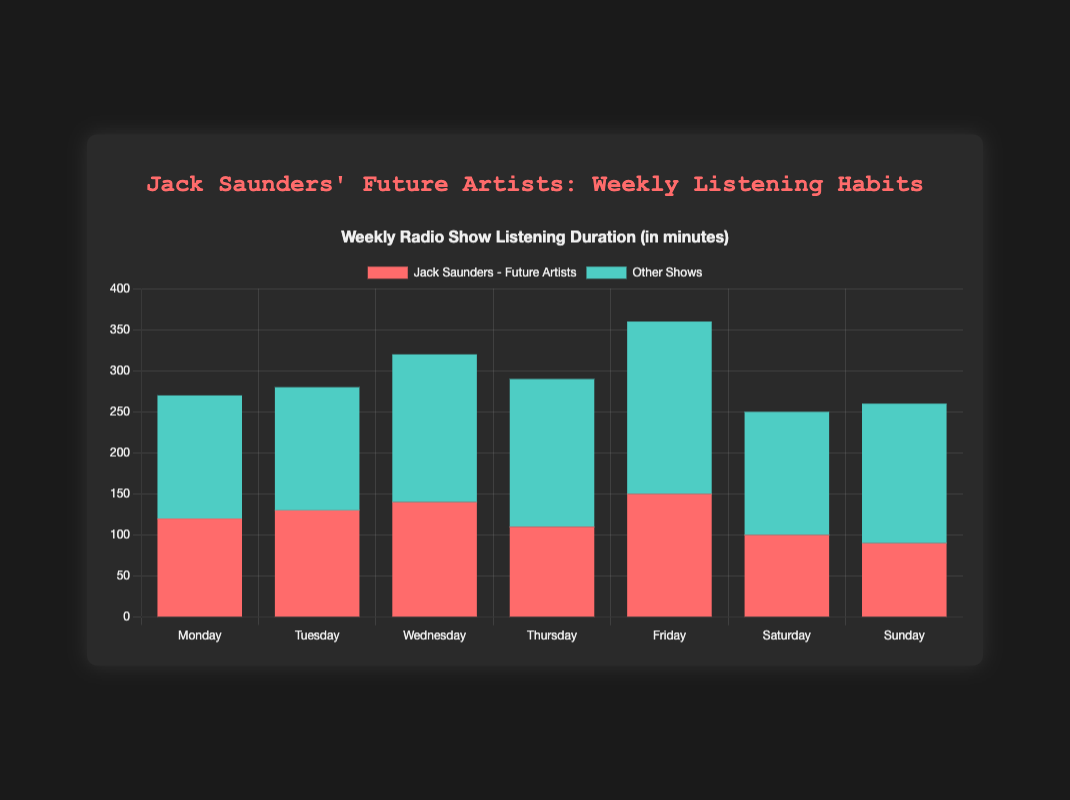Which day has the highest total listening duration? Look for the bar with the greatest height. The total height for each day is the sum of the durations. Friday has the highest total duration.
Answer: Friday Which day has the least amount of listening time to other shows? The "Other Shows" portion of each bar is shown in green. Sunday has the smallest green segment.
Answer: Sunday How much more time is spent listening to Jack Saunders' show on Friday compared to Tuesday? Find the duration of Jack Saunders' show on both days and subtract the duration on Tuesday from Friday. Jack Saunders' show on Friday is 150 minutes, and on Tuesday, it's 130 minutes. So, 150 - 130 = 20.
Answer: 20 minutes What is the average duration of Jack Saunders' show across all days? Sum the durations of Jack Saunders' show and divide by the number of days. (120 + 130 + 140 + 110 + 150 + 100 + 90) / 7 = 120
Answer: 120 minutes Compare the total duration of Monday's listening time to Wednesday's listening time. Which is greater? Add up the durations for both Monday and Wednesday and compare them. Monday's total is 120 + 90 + 60 = 270, and Wednesday's total is 140 + 120 + 60 = 320.
Answer: Wednesday Which day has the largest difference in listening time between Jack Saunders' show and the combined duration of the other shows? Calculate the difference for each day and find the largest. For Monday, the difference is 120 - (90 + 60) = -30. For Tuesday, 130 - (80 + 70) = -20. For Wednesday, 140 - (120 + 60) = -40. For Thursday, 110 - (100 + 80) = -70. For Friday, 150 - (120 + 90) = -60. For Saturday, 100 - (70 + 80) = -50. For Sunday, 90 - (110 + 60) = -80. The largest difference is on Wednesday with -40.
Answer: Wednesday Which visual attribute indicates the duration of Jack Saunders' show? The red portion of each bar represents the duration of Jack Saunders' show.
Answer: Red color What is the total duration of radio shows on Thursday? Sum the durations for Jack Saunders, Annie Mac, and Clara Amfo on Thursday. 110 + 100 + 80 = 290
Answer: 290 minutes How does the total Monday listening duration compare to the total Tuesday listening duration? Calculate the sums for both Monday and Tuesday and compare them. Monday is 120 + 90 + 60 = 270, and Tuesday is 130 + 80 + 70 = 280. Tuesday has 10 more minutes than Monday.
Answer: Tuesday has 10 more minutes than Monday 